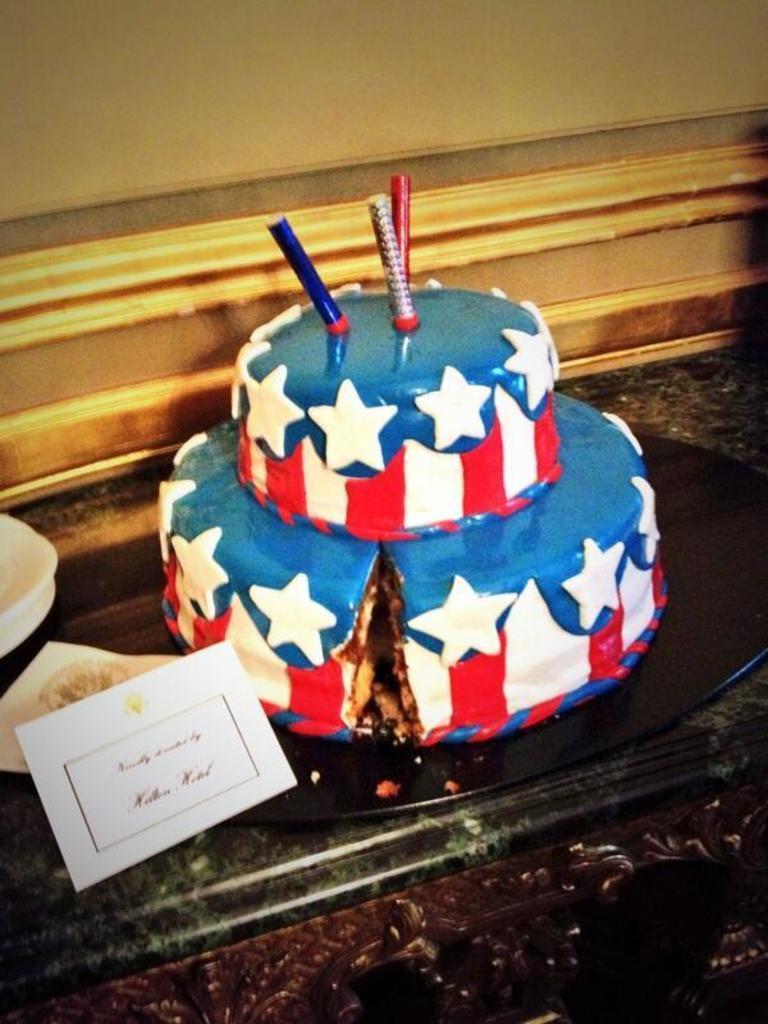What type of dessert can be seen in the image? There is a colorful cake in the image. What is placed on top of the cake? There is a candle on the cake, placed on a plate. What other items can be seen in the image besides the cake? There is a paper visible in the image, as well as bowls. What part of the room can be seen in the image? The wall is visible at the top of the image. What type of squirrel can be seen climbing the wall in the image? There is no squirrel present in the image; only the cake, candle, plate, paper, and bowls are visible. What type of calendar is visible on the wall in the image? There is no calendar present in the image; only the wall is visible at the top of the image. 